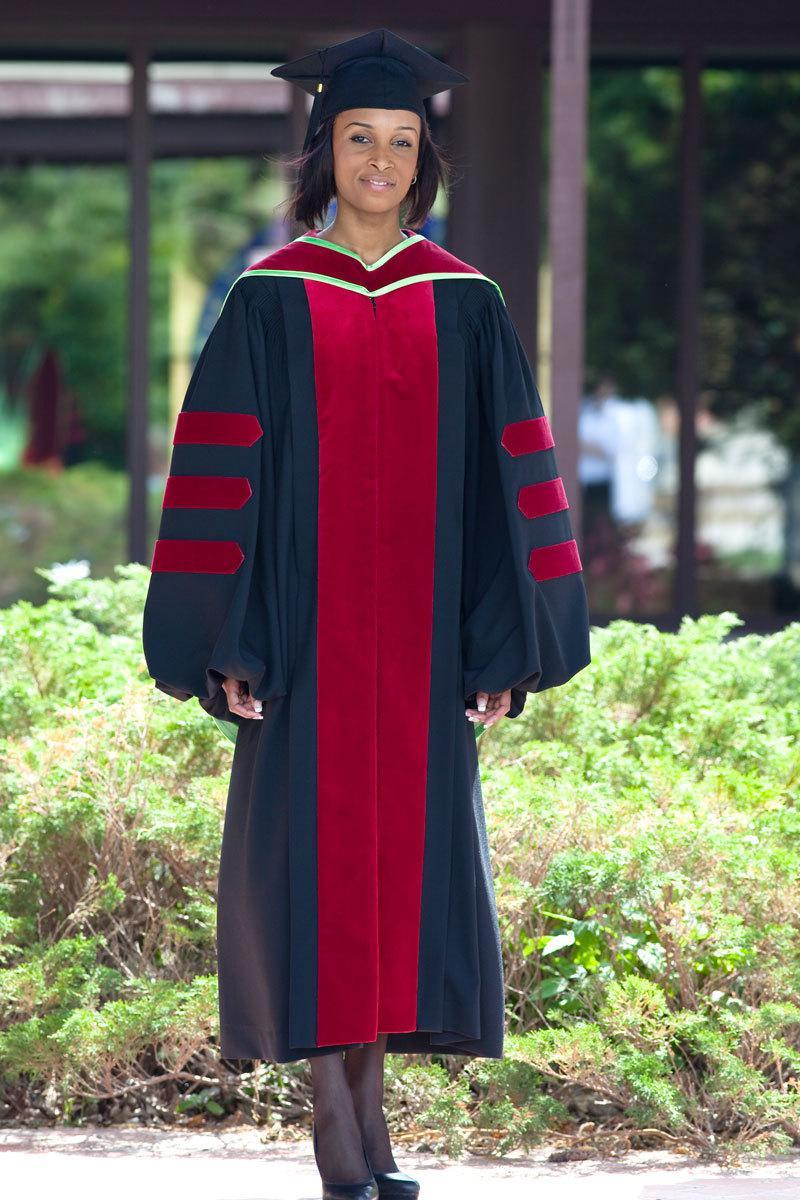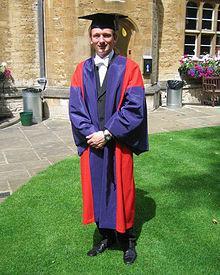The first image is the image on the left, the second image is the image on the right. For the images displayed, is the sentence "No graduate wears glasses, and the graduate in the right image is a male, while the graduate in the left image is female." factually correct? Answer yes or no. Yes. The first image is the image on the left, the second image is the image on the right. Analyze the images presented: Is the assertion "Two people, one man and one woman, wearing graduation gowns and caps, each a different style, are seen facing front in full length photos." valid? Answer yes or no. Yes. 